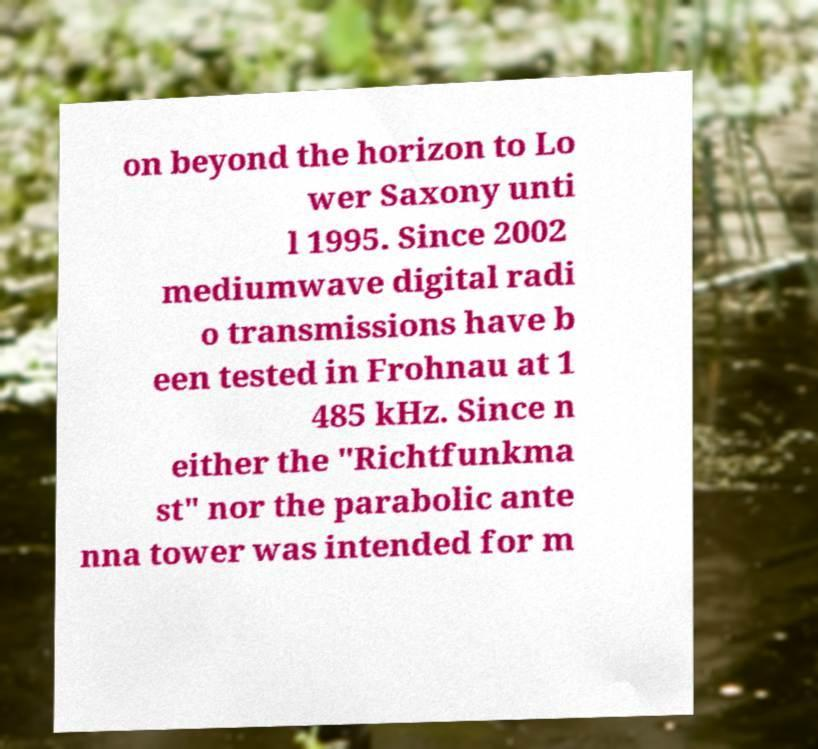What messages or text are displayed in this image? I need them in a readable, typed format. on beyond the horizon to Lo wer Saxony unti l 1995. Since 2002 mediumwave digital radi o transmissions have b een tested in Frohnau at 1 485 kHz. Since n either the "Richtfunkma st" nor the parabolic ante nna tower was intended for m 